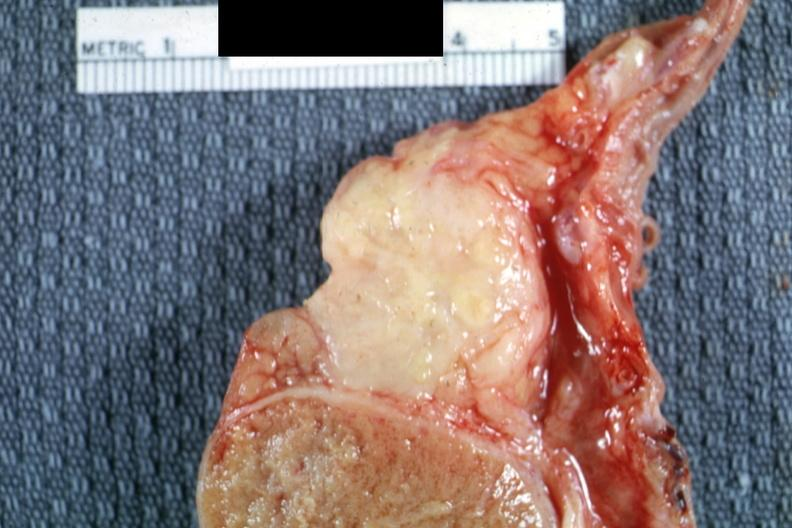what does this image show?
Answer the question using a single word or phrase. Fibrocaseous mass of tissue 